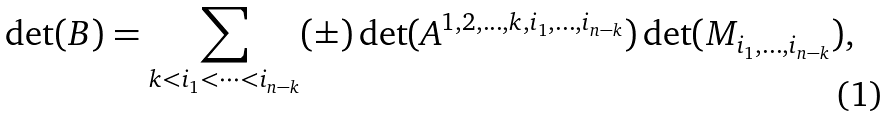Convert formula to latex. <formula><loc_0><loc_0><loc_500><loc_500>\det ( B ) = \sum _ { k < i _ { 1 } < \dots < i _ { n - k } } ( \pm ) \det ( A ^ { 1 , 2 , \dots , k , i _ { 1 } , \dots , i _ { n - k } } ) \det ( M _ { i _ { 1 } , \dots , i _ { n - k } } ) ,</formula> 